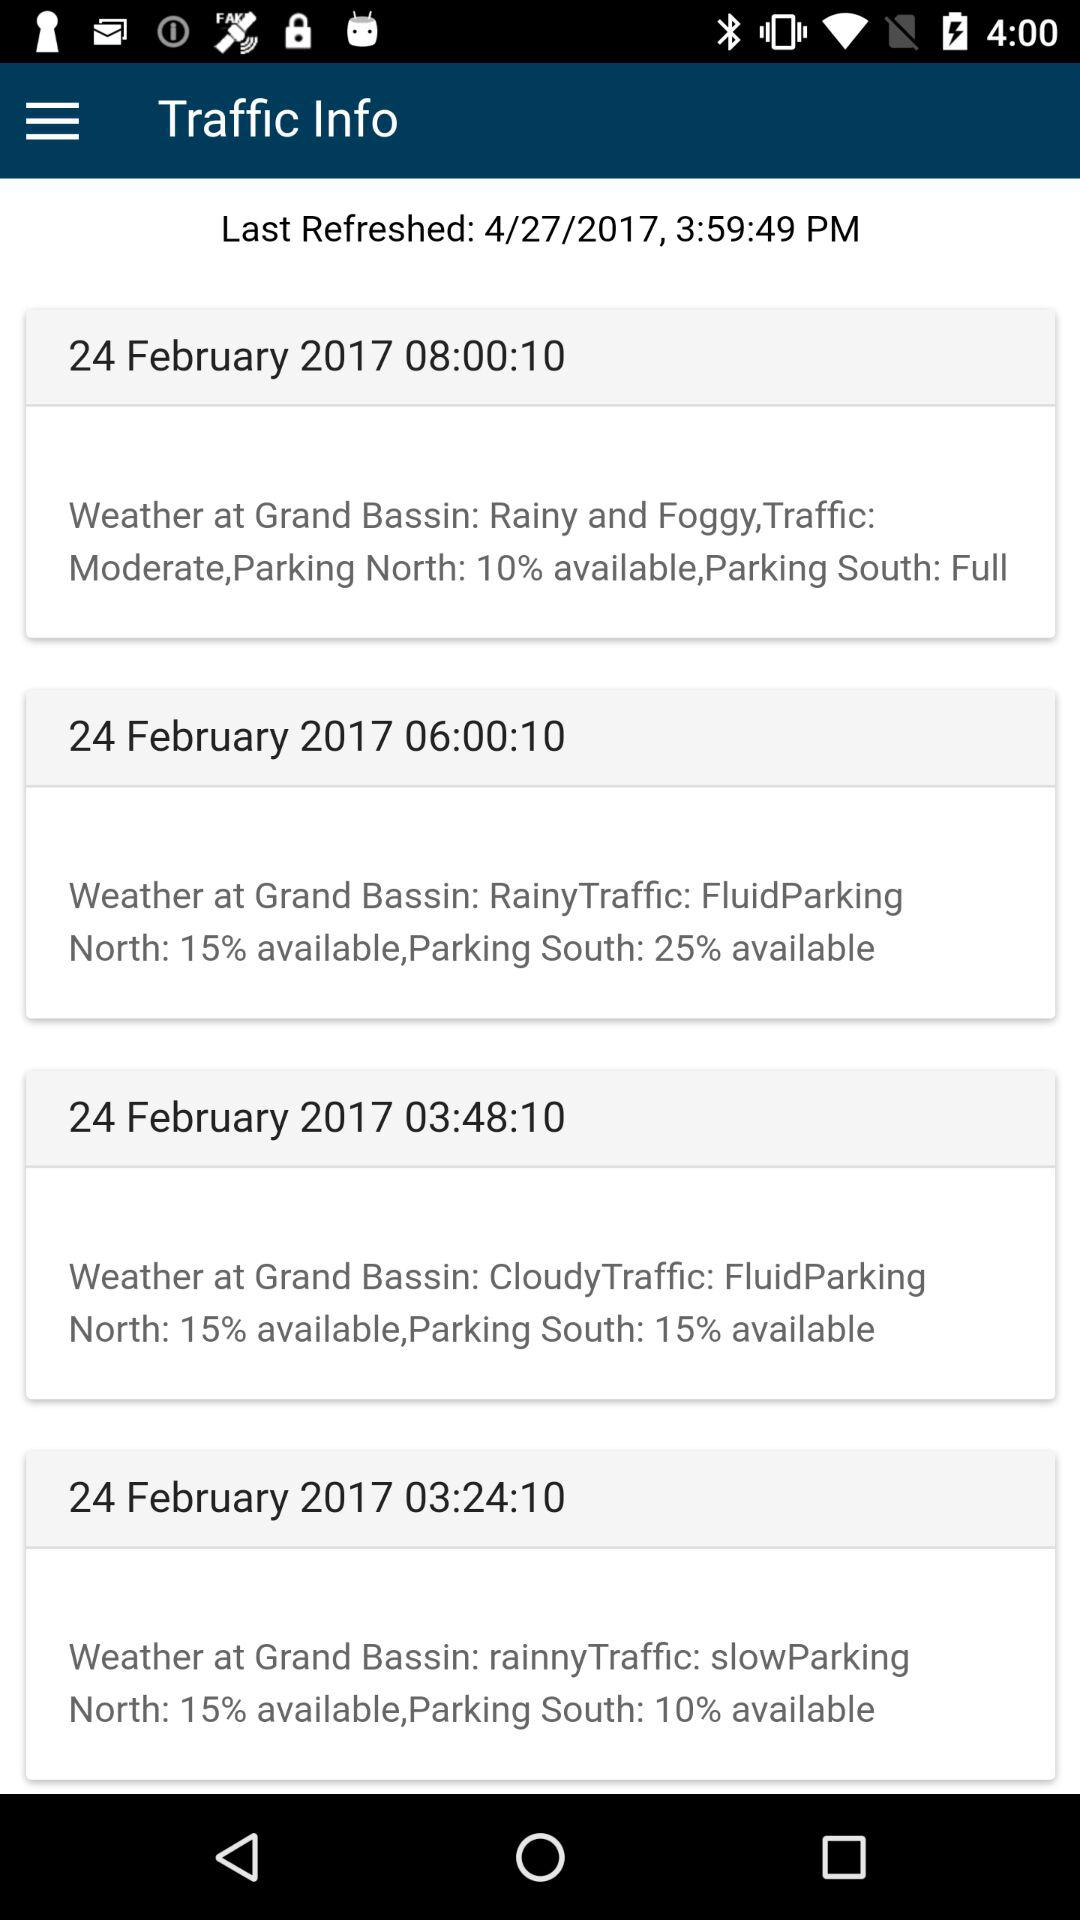For which date is traffic information provided? The traffic information is provided for February 24, 2017. 